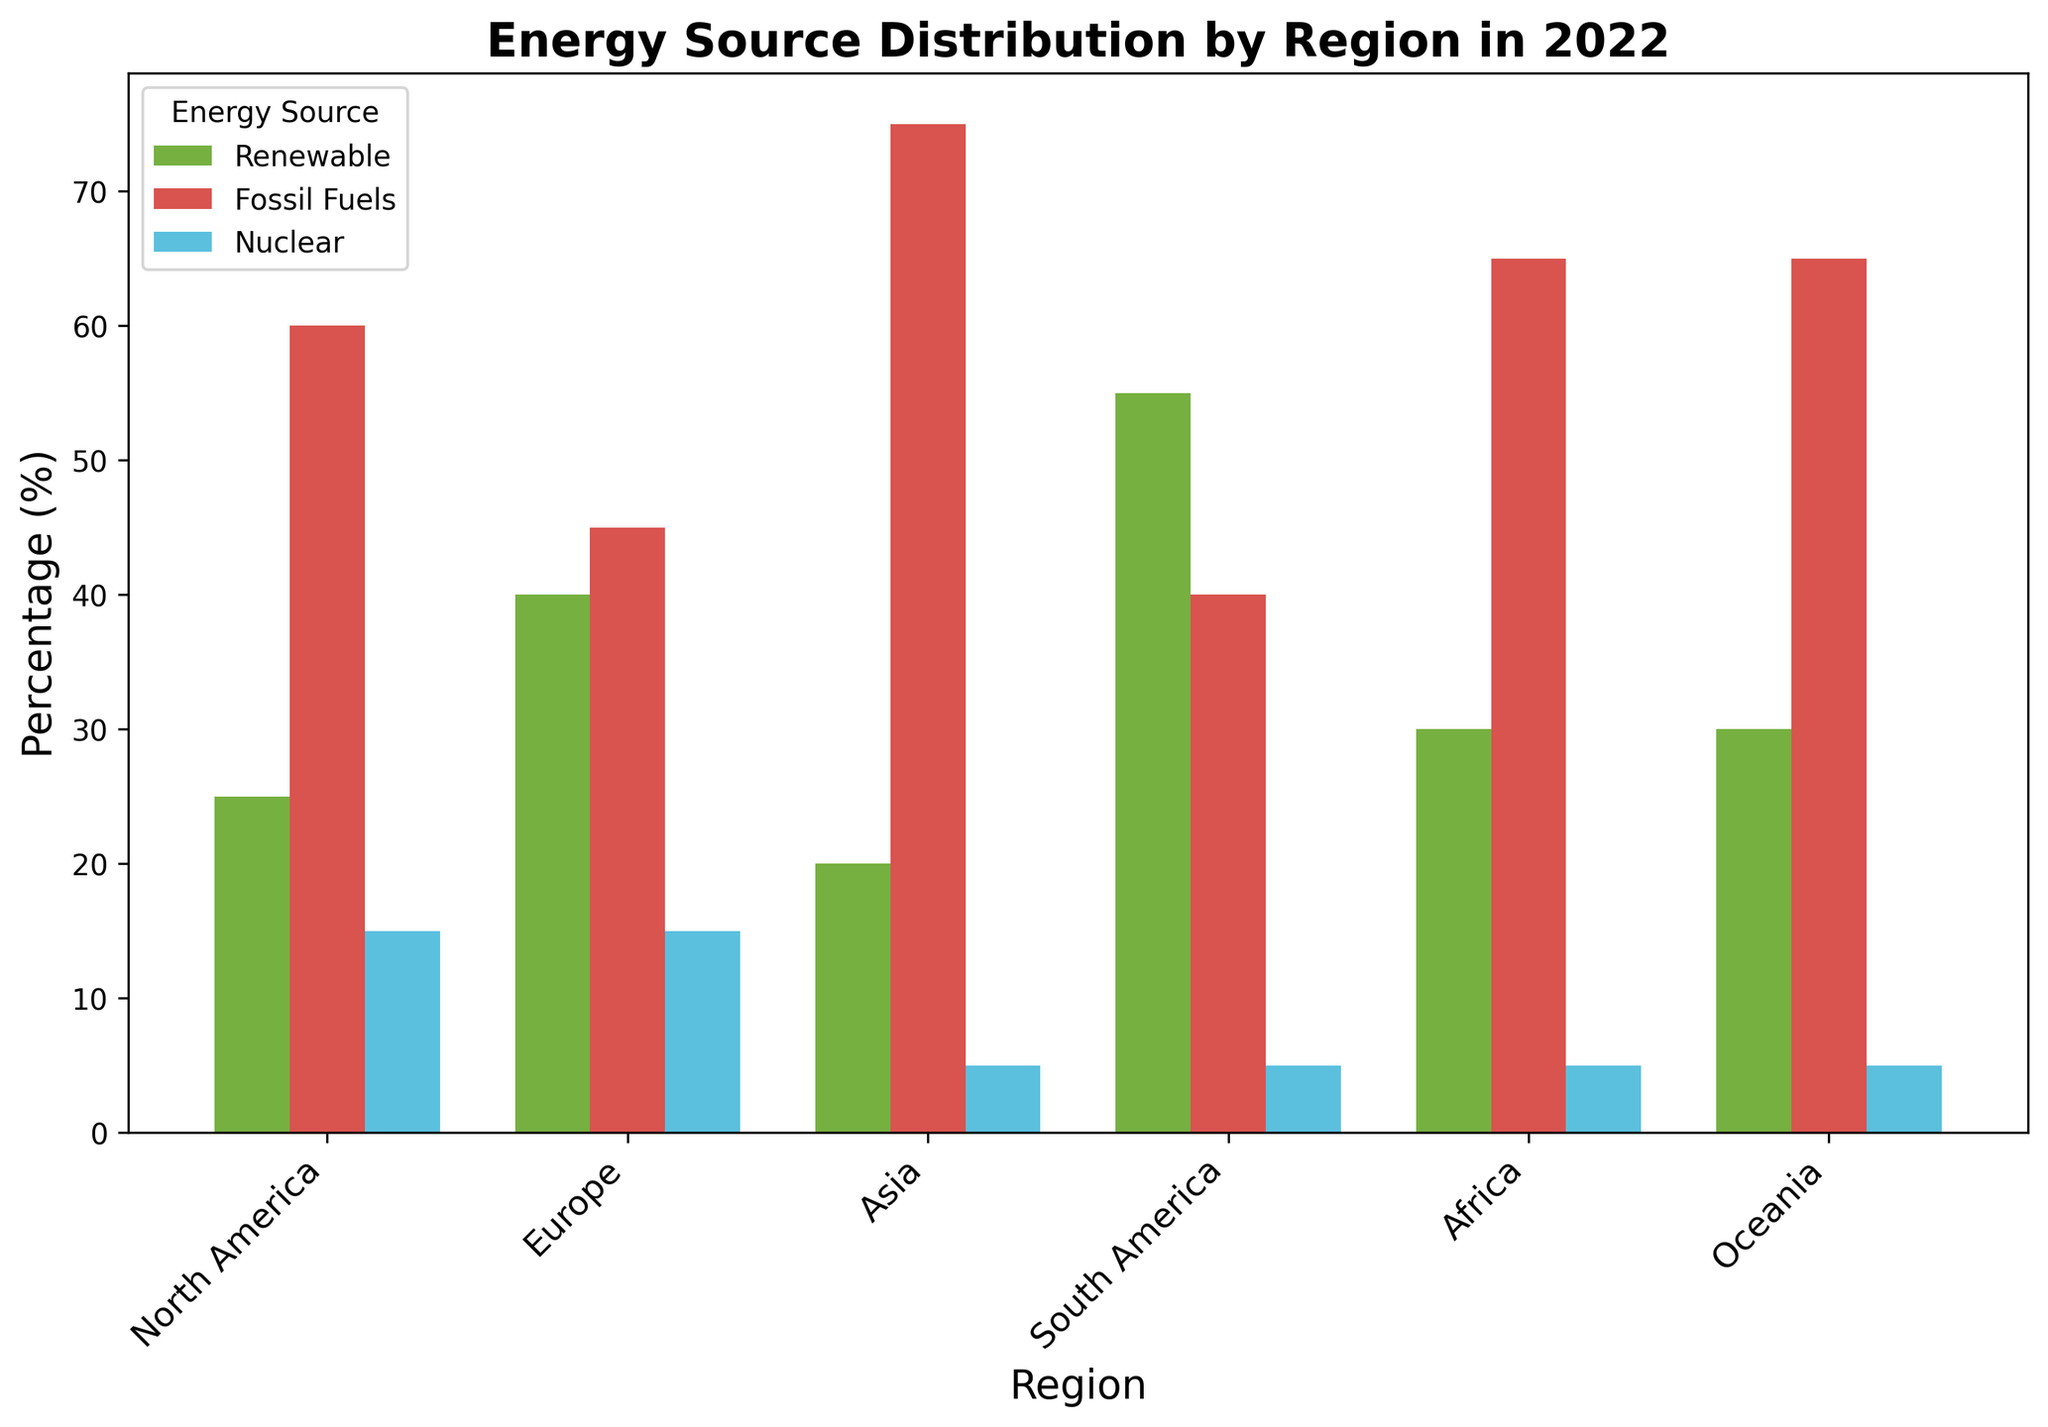Which region has the highest percentage of renewable energy? To find the region with the highest percentage of renewable energy, locate the tallest green bar in the plot, which represents renewable energy for each region.
Answer: South America Which region relies most heavily on fossil fuels? To determine the region that relies most heavily on fossil fuels, find the tallest red bar in the plot, which represents fossil fuels for each region.
Answer: Asia How does the use of nuclear energy in Europe compare to that in North America? Compare the heights of the blue bars representing nuclear energy in Europe and North America. Both bars are of the same height and percentage.
Answer: Equal Which region has the lowest percentage of nuclear energy? Look for the shortest blue bar among all regions, which indicates the region with the lowest percentage of nuclear energy.
Answer: Asia What is the combined percentage of renewable and nuclear energy in Oceania? Sum the percentages represented by the green (renewable) and blue (nuclear) bars for Oceania. Renewable energy is 30% and nuclear energy is 5%. Therefore, 30 + 5 = 35.
Answer: 35 Compare the total fossil fuel consumption of Europe and North America. Which is higher? Compare the heights of the red bars for Europe and North America. North America's fossil fuels percentage is 60%, while Europe's is 45%.
Answer: North America Do any regions have an equal distribution of nuclear energy? Check if there are regions with blue bars (nuclear) of the same height. Both Europe and North America have the same height of blue bars.
Answer: Yes How much more renewable energy does South America use compared to Asia? Subtract the percentage of renewable energy in Asia (20%) from the percentage in South America (55%). 55 - 20 = 35.
Answer: 35 Which regions have the same percentage distribution for nuclear energy? Identify regions whose blue bars representing nuclear energy are of the same height. North America, Europe, Asia, South America, Africa, and Oceania all have 5%. However, only North America and Europe have the same height of 15%.
Answer: North America, Europe (15%) What is the difference between the highest and lowest renewable energy percentages by region? Identify the highest and lowest green bars, which represent renewable energy, and subtract the smallest value from the largest. The highest is 55% (South America), and the lowest is 20% (Asia). Thus, 55 - 20 = 35.
Answer: 35 